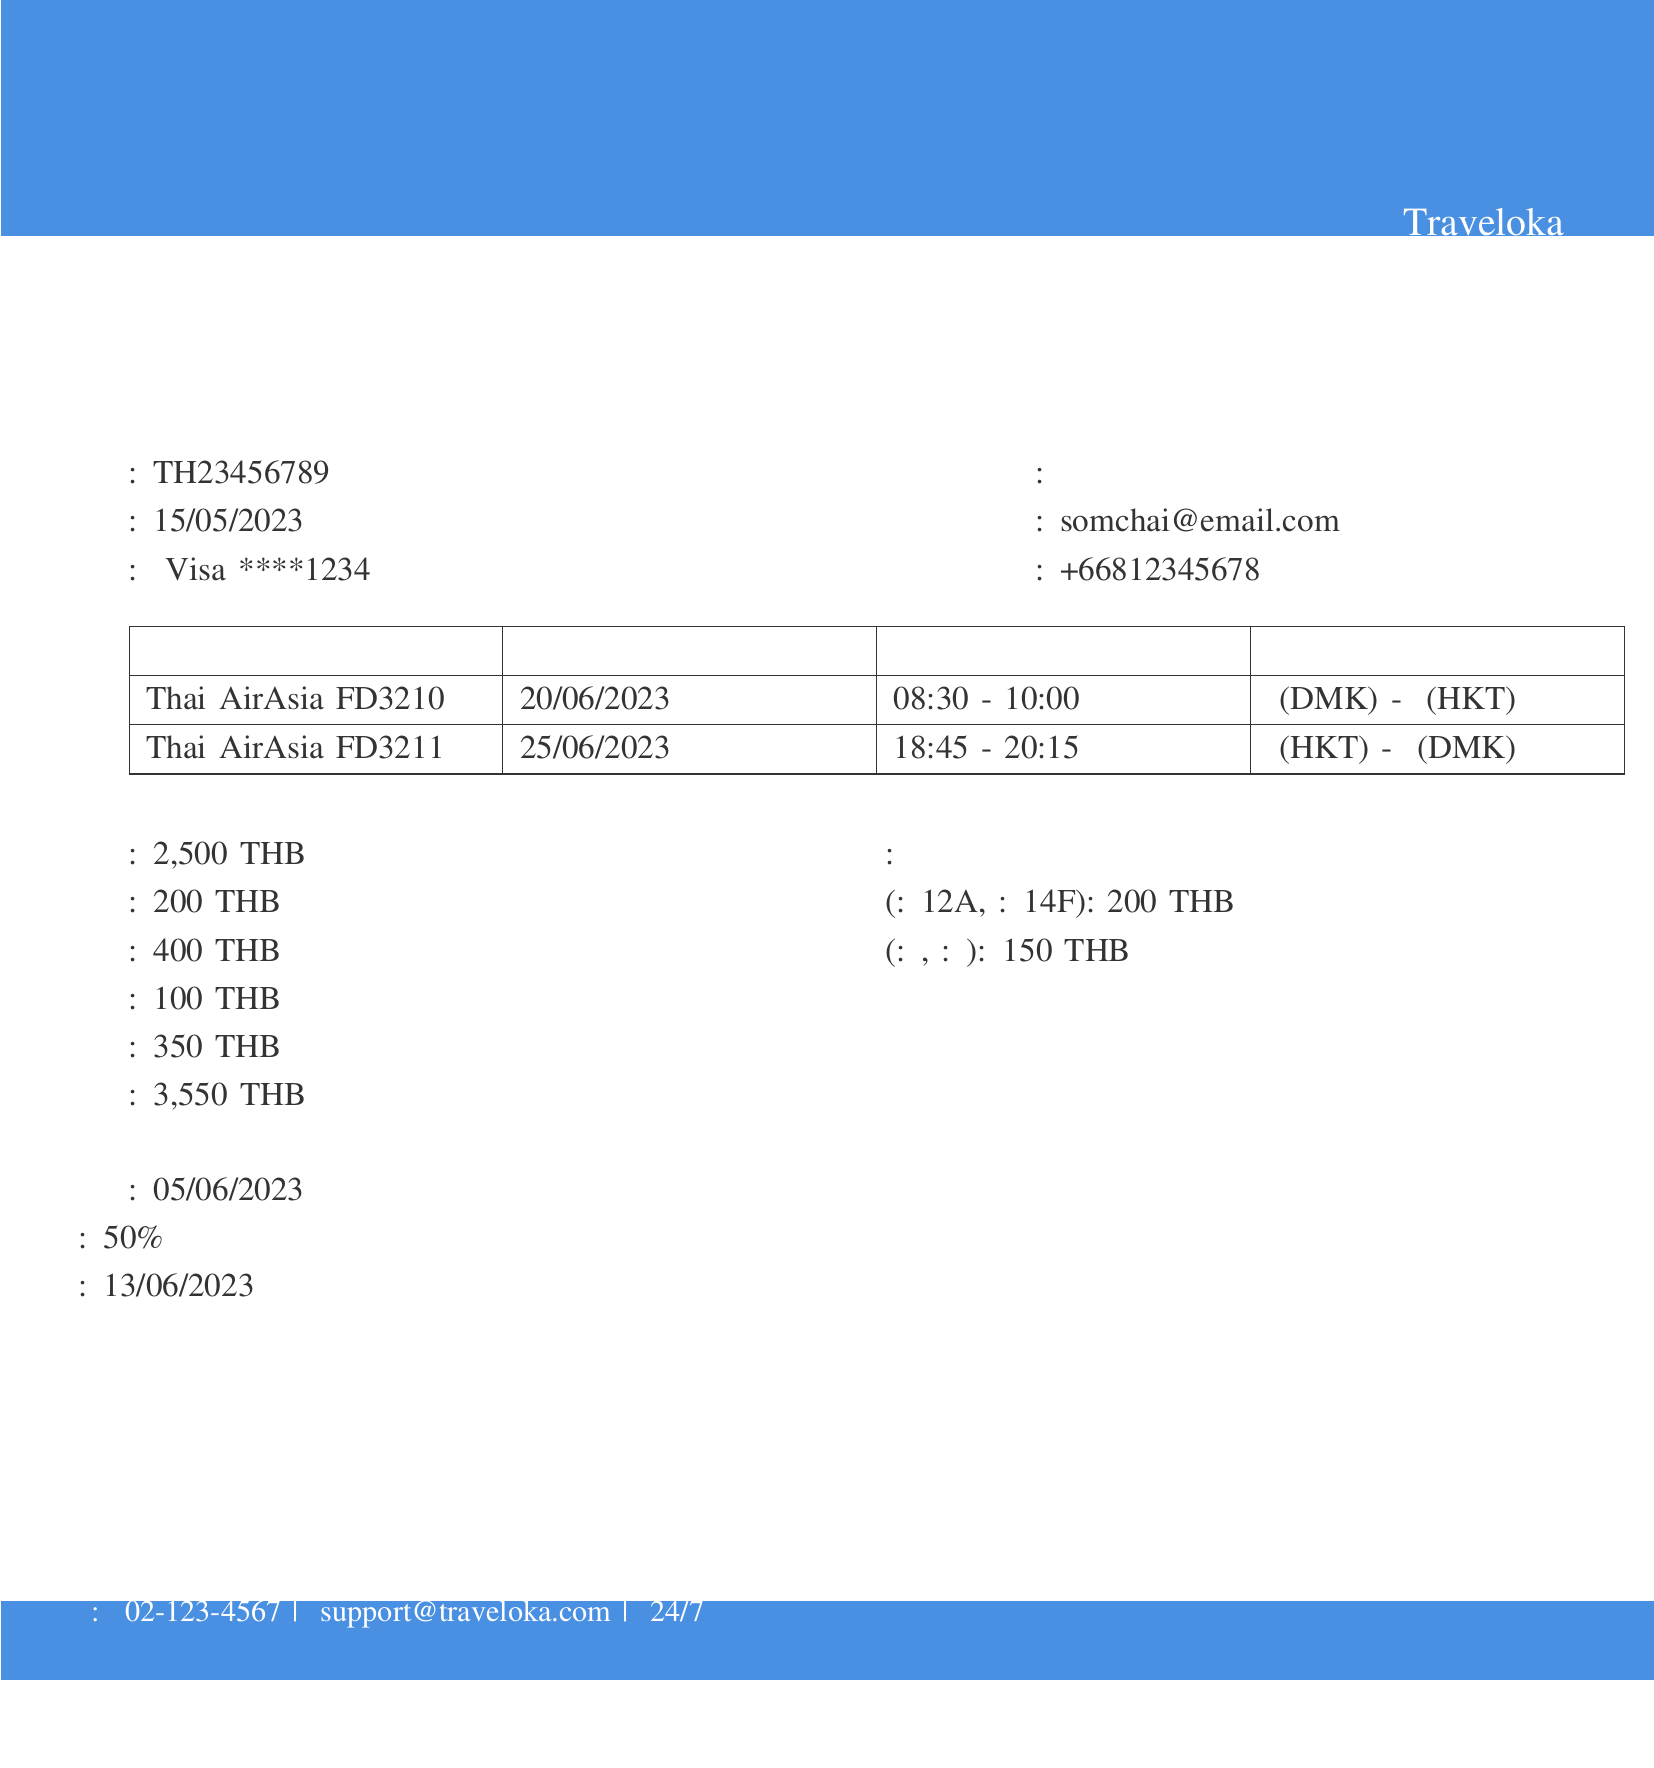เลขที่ใบเสร็จคืออะไร? เลขที่ใบเสร็จสามารถพบได้ในรายละเอียดการจองในเอกสารซึ่งระบุว่าเป็น "TH23456789"
Answer: TH23456789 วันที่จองตั๋วเครื่องบินคือวันไหน? วันที่จองอยู่ในรายละเอียดการจองที่แสดงว่าเป็น "15/05/2023"
Answer: 15/05/2023 ชื่อผู้โดยสารคืออะไร? ชื่อผู้โดยสารได้แก่ "นายสมชาย ใจดี" ซึ่งระบุในข้อมูลผู้โดยสาร
Answer: นายสมชาย ใจดี บินกับสายการบินอะไร? ข้อมูลเกี่ยวกับสายการบินสามารถดูได้ในรายละเอียดเที่ยวบินซึ่งระบุว่าเป็น "Thai AirAsia"
Answer: Thai AirAsia ราคาตั๋วเครื่องบินรวมทั้งหมดคือเท่าไหร่? ราคาตั๋วเครื่องบินรวมทั้งหมดระบุไว้ในรายละเอียดราคา ซึ่งคือ "3,550 THB"
Answer: 3,550 THB เวลาบินขากลับคือเวลาใด? เวลาบินขากลับอยู่ในรายละเอียดเที่ยวบิน ซึ่งระบุว่า "18:45"
Answer: 18:45 นโยบายการยกเลิกคืออะไร? นโยบายการยกเลิกอธิบายไว้ในเอกสารว่า "ยกเลิกฟรีภายในวันที่: 05/06/2023"
Answer: ยกเลิกฟรีภายในวันที่: 05/06/2023 ราคาบริการเสริมที่นั่งคือเท่าไหร่? ราคาสำหรับบริการเสริมที่นั่งระบุว่าเป็น "200 THB"
Answer: 200 THB วันที่ไม่สามารถขอเงินคืนได้หลังจากวันที่ใด? วันที่ไม่สามารถขอเงินคืนได้คือ "13/06/2023"
Answer: 13/06/2023 